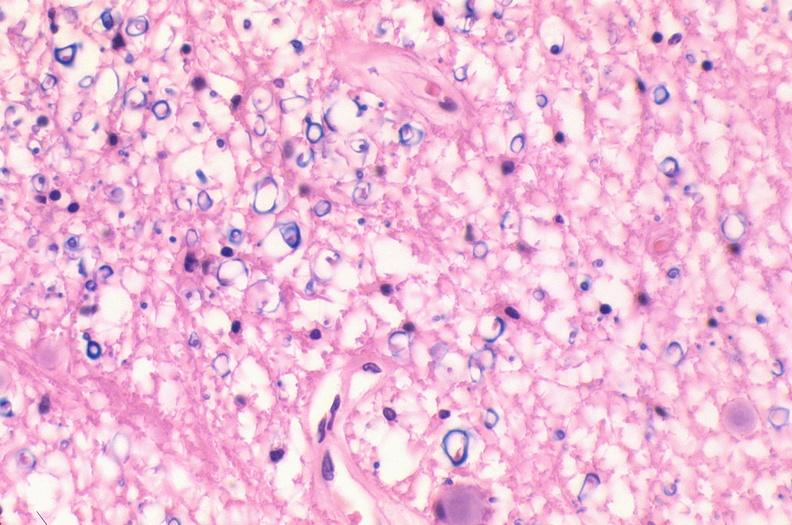what is present?
Answer the question using a single word or phrase. Nervous 